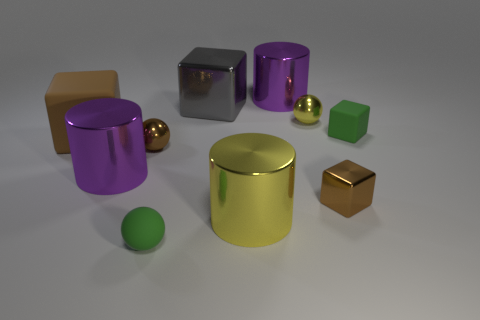Subtract all red spheres. Subtract all yellow cubes. How many spheres are left? 3 Subtract all cylinders. How many objects are left? 7 Subtract 0 purple balls. How many objects are left? 10 Subtract all gray objects. Subtract all gray objects. How many objects are left? 8 Add 6 gray objects. How many gray objects are left? 7 Add 8 big brown things. How many big brown things exist? 9 